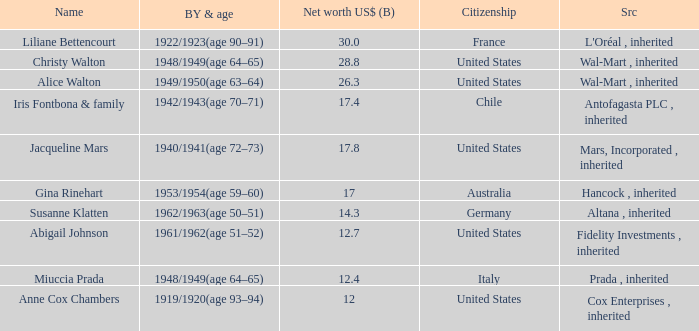Could you parse the entire table as a dict? {'header': ['Name', 'BY & age', 'Net worth US$ (B)', 'Citizenship', 'Src'], 'rows': [['Liliane Bettencourt', '1922/1923(age 90–91)', '30.0', 'France', "L'Oréal , inherited"], ['Christy Walton', '1948/1949(age 64–65)', '28.8', 'United States', 'Wal-Mart , inherited'], ['Alice Walton', '1949/1950(age 63–64)', '26.3', 'United States', 'Wal-Mart , inherited'], ['Iris Fontbona & family', '1942/1943(age 70–71)', '17.4', 'Chile', 'Antofagasta PLC , inherited'], ['Jacqueline Mars', '1940/1941(age 72–73)', '17.8', 'United States', 'Mars, Incorporated , inherited'], ['Gina Rinehart', '1953/1954(age 59–60)', '17', 'Australia', 'Hancock , inherited'], ['Susanne Klatten', '1962/1963(age 50–51)', '14.3', 'Germany', 'Altana , inherited'], ['Abigail Johnson', '1961/1962(age 51–52)', '12.7', 'United States', 'Fidelity Investments , inherited'], ['Miuccia Prada', '1948/1949(age 64–65)', '12.4', 'Italy', 'Prada , inherited'], ['Anne Cox Chambers', '1919/1920(age 93–94)', '12', 'United States', 'Cox Enterprises , inherited']]} What's the source of wealth of the person worth $17 billion? Hancock , inherited. 